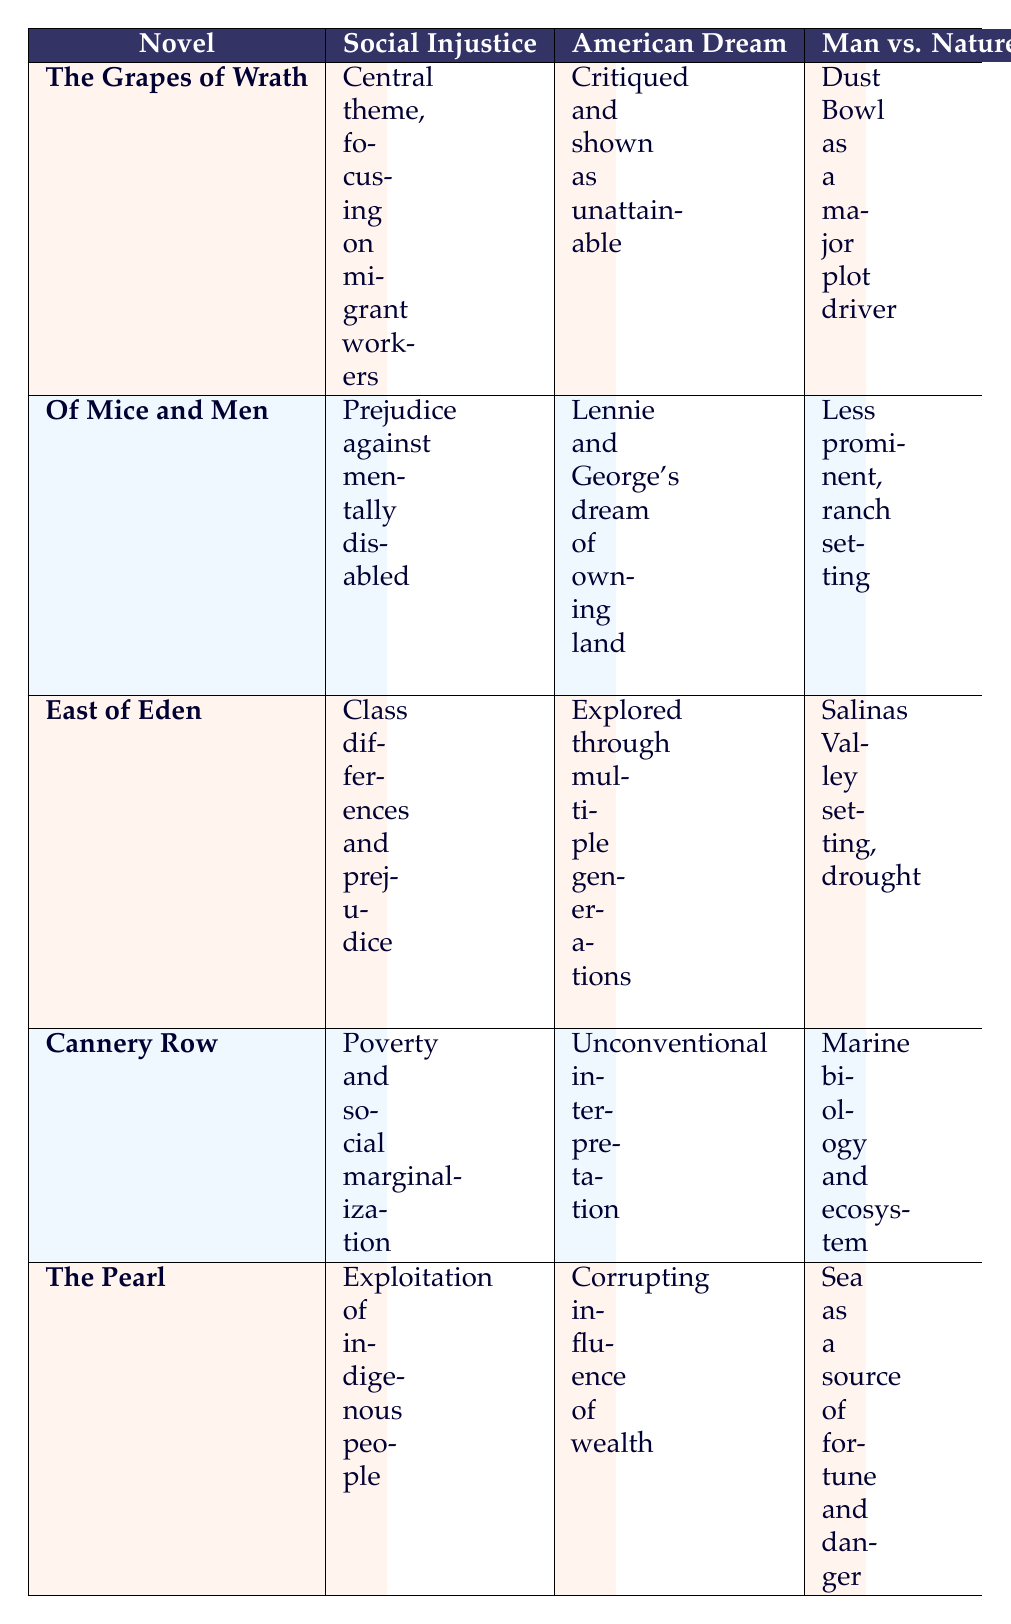What is the main theme of "The Grapes of Wrath"? The main theme of "The Grapes of Wrath" is social injustice, as it focuses on the challenges faced by migrant workers during the Dust Bowl. This is clearly stated in the table under the "Social Injustice" column for that novel.
Answer: Social injustice Which novel critiques the American Dream as unattainable? "The Grapes of Wrath" critiques the American Dream by portraying it as unattainable, which is indicated in the table under the "American Dream" column for that novel.
Answer: The Grapes of Wrath Does "Of Mice and Men" focus on family bonds? No, "Of Mice and Men" does not focus on family bonds, as it explicitly states that family bonds are not a major focus in the table.
Answer: No What are two themes present in "East of Eden"? The two prominent themes in "East of Eden" are social injustice, which deals with class differences and prejudice, and family bonds, which are central to the Trask and Hamilton families as indicated in the respective columns.
Answer: Social injustice, family bonds Which novel has a friendship theme centered on a community of misfits? "Cannery Row" has a friendship theme centered on a community of misfits, as highlighted in the “Friendship” column for that novel.
Answer: Cannery Row What is the relationship between man and nature in "The Pearl"? In "The Pearl", the relationship is characterized by the sea being a source of both fortune and danger, as stated in the "Man vs. Nature" column in the table.
Answer: Sea as a source of fortune and danger How many novels explore the theme of the American Dream? Three novels explore the theme of the American Dream: "The Grapes of Wrath", "Of Mice and Men", and "East of Eden". This can be verified by counting the entries under the "American Dream" column, which provides insights for each of these novels.
Answer: Three Are friendship and family bonds equally significant in "The Pearl"? No, friendship does not play a significant role in "The Pearl" compared to family bonds, which are central to the story focusing on Kino's family. The table shows a contrast between these themes for this novel.
Answer: No Which novel discusses the exploitation of indigenous people? "The Pearl" discusses the exploitation of indigenous people, as stated in the Social Injustice column.
Answer: The Pearl 